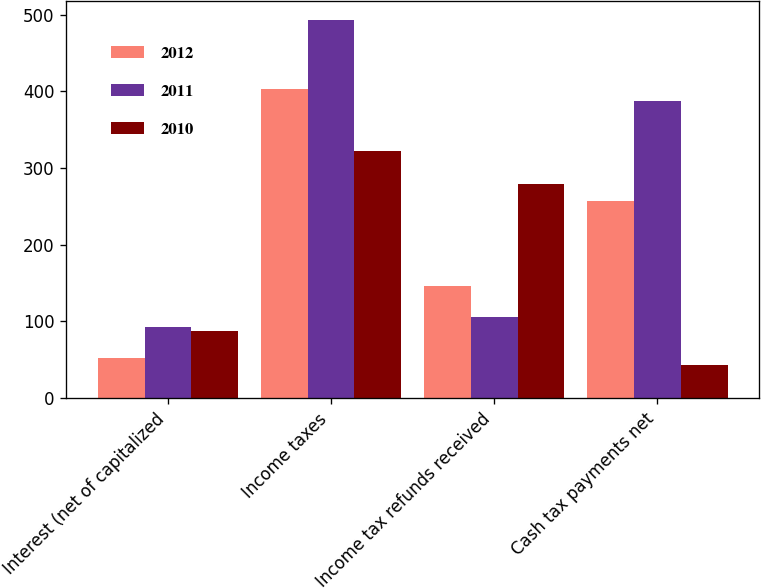Convert chart. <chart><loc_0><loc_0><loc_500><loc_500><stacked_bar_chart><ecel><fcel>Interest (net of capitalized<fcel>Income taxes<fcel>Income tax refunds received<fcel>Cash tax payments net<nl><fcel>2012<fcel>52<fcel>403<fcel>146<fcel>257<nl><fcel>2011<fcel>93<fcel>493<fcel>106<fcel>387<nl><fcel>2010<fcel>88<fcel>322<fcel>279<fcel>43<nl></chart> 